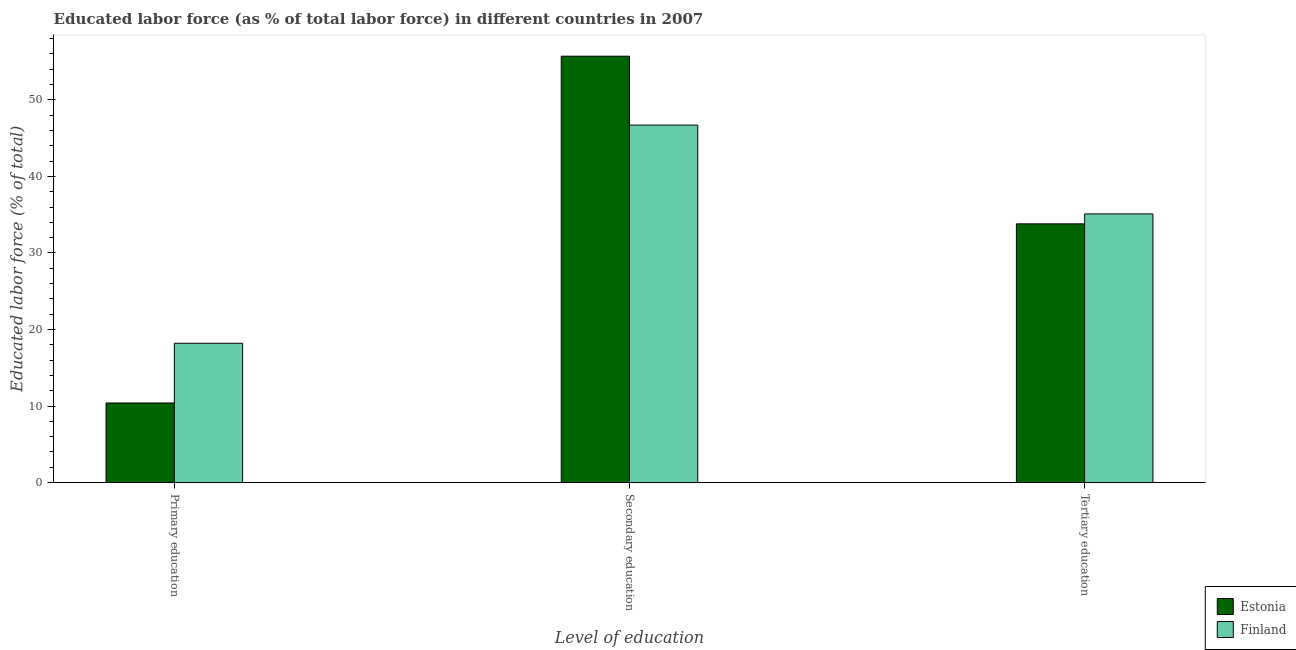How many different coloured bars are there?
Offer a terse response. 2. Are the number of bars on each tick of the X-axis equal?
Ensure brevity in your answer.  Yes. How many bars are there on the 2nd tick from the left?
Give a very brief answer. 2. What is the label of the 1st group of bars from the left?
Keep it short and to the point. Primary education. What is the percentage of labor force who received tertiary education in Finland?
Offer a very short reply. 35.1. Across all countries, what is the maximum percentage of labor force who received primary education?
Your answer should be very brief. 18.2. Across all countries, what is the minimum percentage of labor force who received primary education?
Make the answer very short. 10.4. In which country was the percentage of labor force who received primary education maximum?
Make the answer very short. Finland. In which country was the percentage of labor force who received tertiary education minimum?
Keep it short and to the point. Estonia. What is the total percentage of labor force who received primary education in the graph?
Offer a very short reply. 28.6. What is the difference between the percentage of labor force who received primary education in Finland and that in Estonia?
Your response must be concise. 7.8. What is the difference between the percentage of labor force who received secondary education in Estonia and the percentage of labor force who received primary education in Finland?
Your response must be concise. 37.5. What is the average percentage of labor force who received primary education per country?
Give a very brief answer. 14.3. What is the difference between the percentage of labor force who received primary education and percentage of labor force who received tertiary education in Finland?
Keep it short and to the point. -16.9. What is the ratio of the percentage of labor force who received tertiary education in Estonia to that in Finland?
Give a very brief answer. 0.96. Is the percentage of labor force who received secondary education in Estonia less than that in Finland?
Give a very brief answer. No. Is the difference between the percentage of labor force who received primary education in Finland and Estonia greater than the difference between the percentage of labor force who received tertiary education in Finland and Estonia?
Ensure brevity in your answer.  Yes. What is the difference between the highest and the second highest percentage of labor force who received secondary education?
Make the answer very short. 9. What is the difference between the highest and the lowest percentage of labor force who received secondary education?
Make the answer very short. 9. Is the sum of the percentage of labor force who received secondary education in Finland and Estonia greater than the maximum percentage of labor force who received tertiary education across all countries?
Ensure brevity in your answer.  Yes. What does the 2nd bar from the left in Primary education represents?
Provide a succinct answer. Finland. What does the 2nd bar from the right in Secondary education represents?
Ensure brevity in your answer.  Estonia. Does the graph contain any zero values?
Ensure brevity in your answer.  No. Does the graph contain grids?
Make the answer very short. No. Where does the legend appear in the graph?
Make the answer very short. Bottom right. How many legend labels are there?
Keep it short and to the point. 2. How are the legend labels stacked?
Give a very brief answer. Vertical. What is the title of the graph?
Offer a very short reply. Educated labor force (as % of total labor force) in different countries in 2007. What is the label or title of the X-axis?
Your answer should be compact. Level of education. What is the label or title of the Y-axis?
Make the answer very short. Educated labor force (% of total). What is the Educated labor force (% of total) of Estonia in Primary education?
Provide a short and direct response. 10.4. What is the Educated labor force (% of total) of Finland in Primary education?
Keep it short and to the point. 18.2. What is the Educated labor force (% of total) in Estonia in Secondary education?
Keep it short and to the point. 55.7. What is the Educated labor force (% of total) of Finland in Secondary education?
Your answer should be compact. 46.7. What is the Educated labor force (% of total) of Estonia in Tertiary education?
Your answer should be compact. 33.8. What is the Educated labor force (% of total) of Finland in Tertiary education?
Your answer should be compact. 35.1. Across all Level of education, what is the maximum Educated labor force (% of total) in Estonia?
Keep it short and to the point. 55.7. Across all Level of education, what is the maximum Educated labor force (% of total) of Finland?
Your answer should be very brief. 46.7. Across all Level of education, what is the minimum Educated labor force (% of total) in Estonia?
Offer a terse response. 10.4. Across all Level of education, what is the minimum Educated labor force (% of total) of Finland?
Provide a short and direct response. 18.2. What is the total Educated labor force (% of total) in Estonia in the graph?
Offer a very short reply. 99.9. What is the difference between the Educated labor force (% of total) of Estonia in Primary education and that in Secondary education?
Your answer should be compact. -45.3. What is the difference between the Educated labor force (% of total) in Finland in Primary education and that in Secondary education?
Keep it short and to the point. -28.5. What is the difference between the Educated labor force (% of total) in Estonia in Primary education and that in Tertiary education?
Offer a very short reply. -23.4. What is the difference between the Educated labor force (% of total) of Finland in Primary education and that in Tertiary education?
Give a very brief answer. -16.9. What is the difference between the Educated labor force (% of total) of Estonia in Secondary education and that in Tertiary education?
Your answer should be compact. 21.9. What is the difference between the Educated labor force (% of total) in Finland in Secondary education and that in Tertiary education?
Offer a terse response. 11.6. What is the difference between the Educated labor force (% of total) in Estonia in Primary education and the Educated labor force (% of total) in Finland in Secondary education?
Your response must be concise. -36.3. What is the difference between the Educated labor force (% of total) of Estonia in Primary education and the Educated labor force (% of total) of Finland in Tertiary education?
Provide a succinct answer. -24.7. What is the difference between the Educated labor force (% of total) in Estonia in Secondary education and the Educated labor force (% of total) in Finland in Tertiary education?
Your answer should be very brief. 20.6. What is the average Educated labor force (% of total) of Estonia per Level of education?
Offer a terse response. 33.3. What is the average Educated labor force (% of total) in Finland per Level of education?
Keep it short and to the point. 33.33. What is the difference between the Educated labor force (% of total) in Estonia and Educated labor force (% of total) in Finland in Primary education?
Provide a succinct answer. -7.8. What is the difference between the Educated labor force (% of total) of Estonia and Educated labor force (% of total) of Finland in Secondary education?
Offer a terse response. 9. What is the ratio of the Educated labor force (% of total) in Estonia in Primary education to that in Secondary education?
Keep it short and to the point. 0.19. What is the ratio of the Educated labor force (% of total) of Finland in Primary education to that in Secondary education?
Keep it short and to the point. 0.39. What is the ratio of the Educated labor force (% of total) in Estonia in Primary education to that in Tertiary education?
Your answer should be very brief. 0.31. What is the ratio of the Educated labor force (% of total) in Finland in Primary education to that in Tertiary education?
Make the answer very short. 0.52. What is the ratio of the Educated labor force (% of total) in Estonia in Secondary education to that in Tertiary education?
Offer a terse response. 1.65. What is the ratio of the Educated labor force (% of total) in Finland in Secondary education to that in Tertiary education?
Your response must be concise. 1.33. What is the difference between the highest and the second highest Educated labor force (% of total) in Estonia?
Provide a succinct answer. 21.9. What is the difference between the highest and the second highest Educated labor force (% of total) of Finland?
Provide a succinct answer. 11.6. What is the difference between the highest and the lowest Educated labor force (% of total) of Estonia?
Provide a short and direct response. 45.3. What is the difference between the highest and the lowest Educated labor force (% of total) in Finland?
Your answer should be very brief. 28.5. 